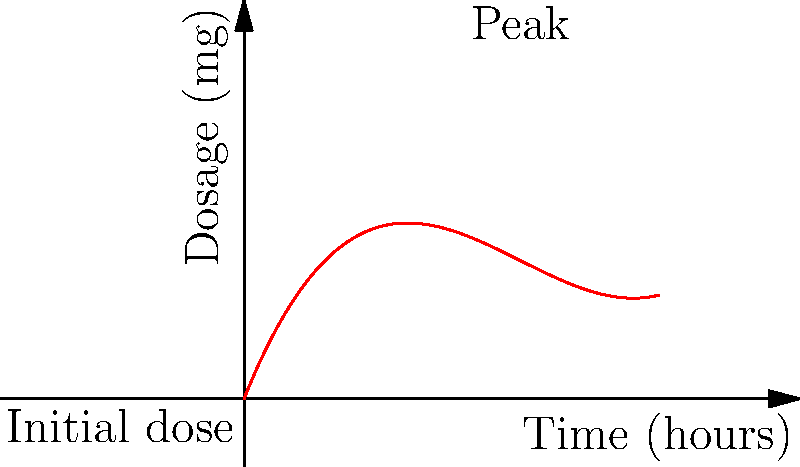As a parent familiar with pediatric medications, you're monitoring your child's acetaminophen levels. The graph shows the concentration of the medication in their system over time. The function $f(x) = 0.0625x^3 - 0.75x^2 + 2.5x$ represents the dosage in milligrams, where $x$ is time in hours. At what time does the medication reach its peak concentration? To find the peak concentration, we need to determine when the derivative of the function equals zero:

1) First, let's find the derivative of $f(x)$:
   $f'(x) = 0.1875x^2 - 1.5x + 2.5$

2) Set the derivative equal to zero:
   $0.1875x^2 - 1.5x + 2.5 = 0$

3) This is a quadratic equation. We can solve it using the quadratic formula:
   $x = \frac{-b \pm \sqrt{b^2 - 4ac}}{2a}$

   Where $a = 0.1875$, $b = -1.5$, and $c = 2.5$

4) Plugging these values into the quadratic formula:
   $x = \frac{1.5 \pm \sqrt{(-1.5)^2 - 4(0.1875)(2.5)}}{2(0.1875)}$

5) Simplifying:
   $x = \frac{1.5 \pm \sqrt{2.25 - 1.875}}{0.375} = \frac{1.5 \pm \sqrt{0.375}}{0.375}$

6) Calculating:
   $x \approx 4$ or $x \approx 2.67$

7) Since we're looking for the peak (maximum), we choose the larger value, $x = 4$.

Therefore, the medication reaches its peak concentration at 4 hours after administration.
Answer: 4 hours 